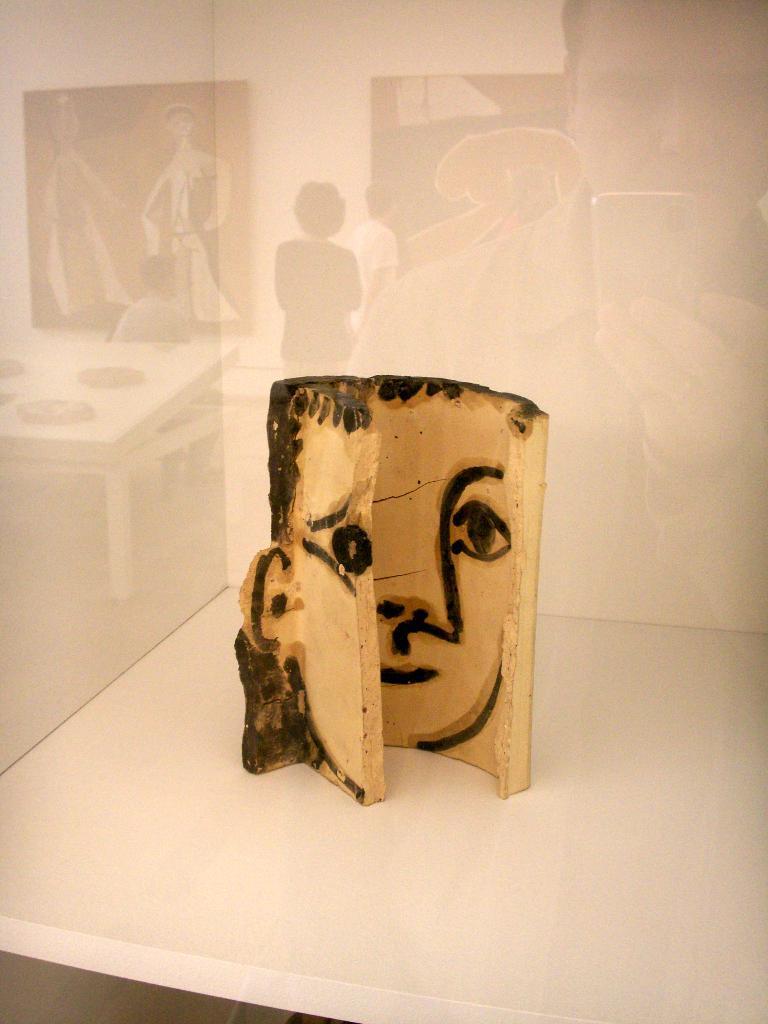Describe this image in one or two sentences. In the center of the image we can see one table. On the table, we can see one wooden object, in which we can see one human face. In the background there is a glass wall. On the glass wall, we can see the reflection of a few people, one table, frame type objects and a few other objects. 